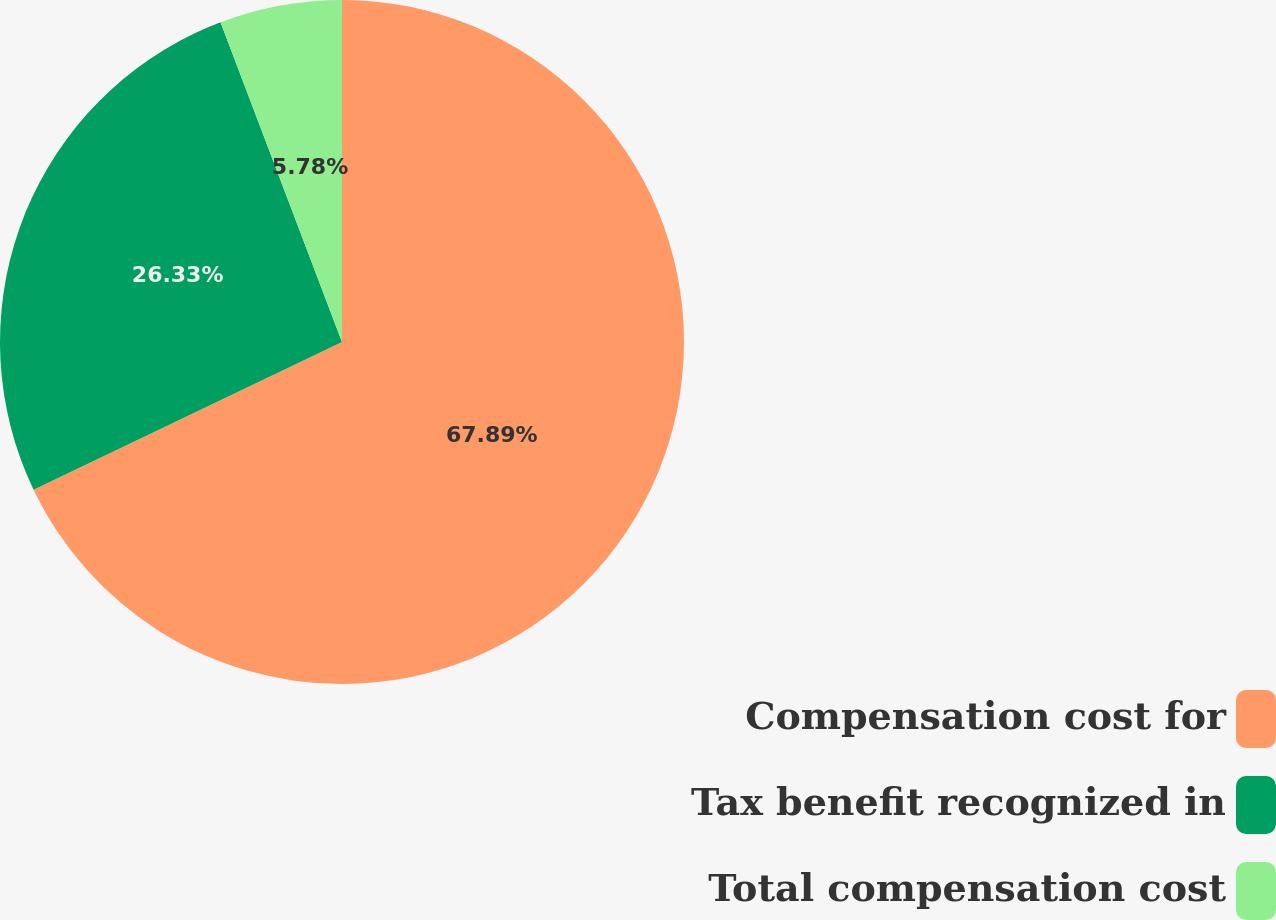Convert chart to OTSL. <chart><loc_0><loc_0><loc_500><loc_500><pie_chart><fcel>Compensation cost for<fcel>Tax benefit recognized in<fcel>Total compensation cost<nl><fcel>67.89%<fcel>26.33%<fcel>5.78%<nl></chart> 